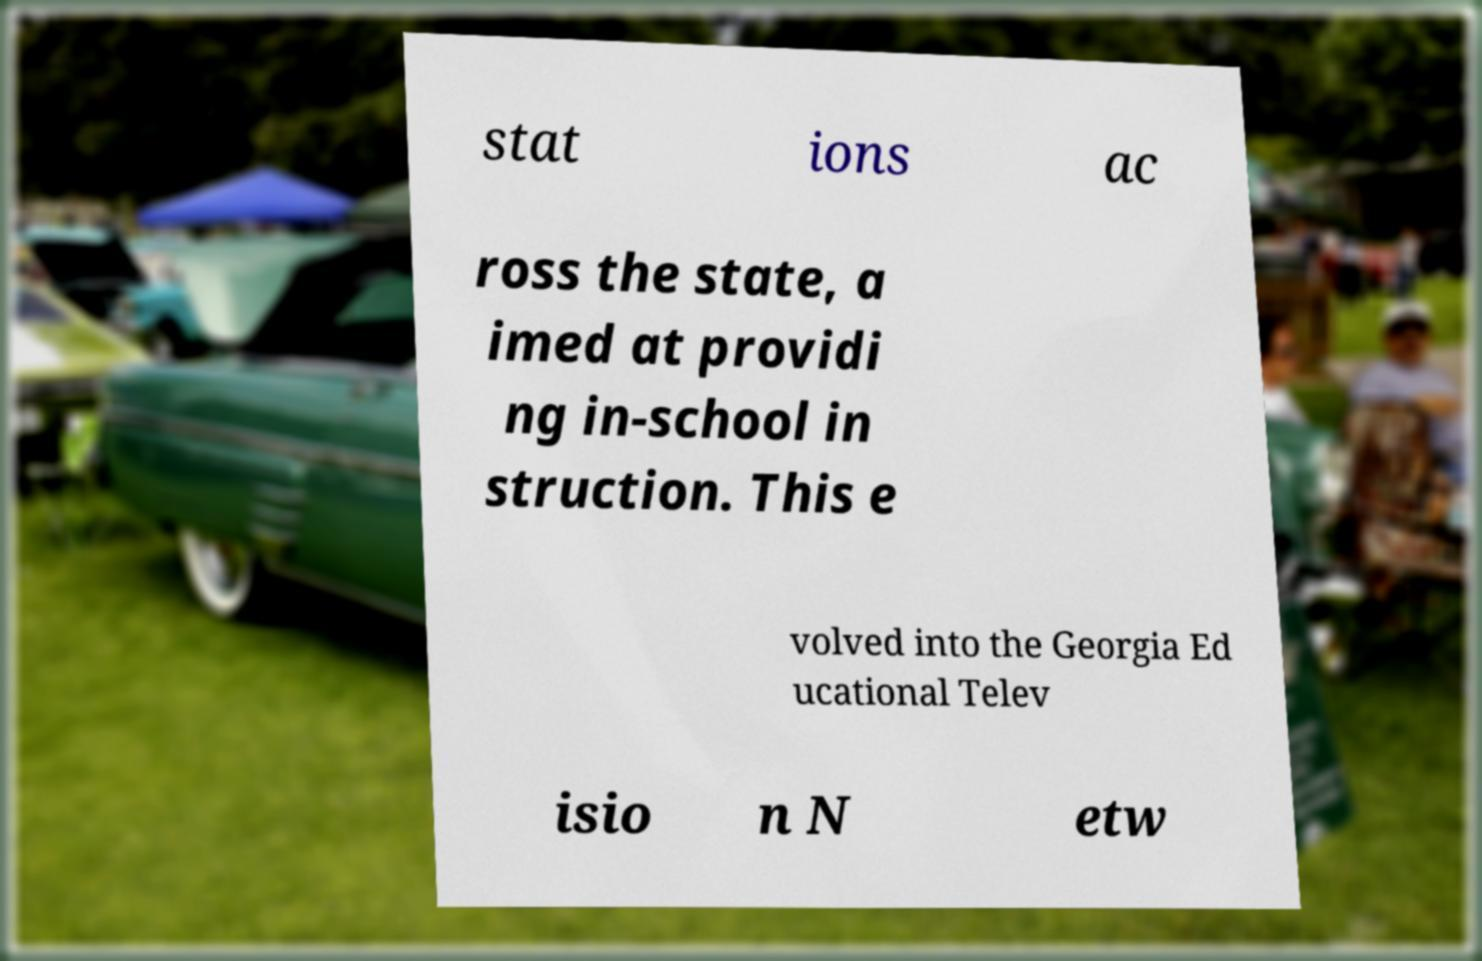Can you accurately transcribe the text from the provided image for me? stat ions ac ross the state, a imed at providi ng in-school in struction. This e volved into the Georgia Ed ucational Telev isio n N etw 